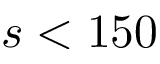<formula> <loc_0><loc_0><loc_500><loc_500>s < 1 5 0</formula> 